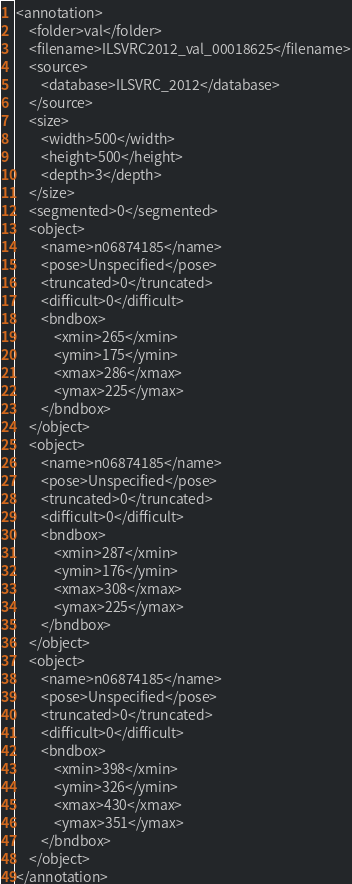<code> <loc_0><loc_0><loc_500><loc_500><_XML_><annotation>
	<folder>val</folder>
	<filename>ILSVRC2012_val_00018625</filename>
	<source>
		<database>ILSVRC_2012</database>
	</source>
	<size>
		<width>500</width>
		<height>500</height>
		<depth>3</depth>
	</size>
	<segmented>0</segmented>
	<object>
		<name>n06874185</name>
		<pose>Unspecified</pose>
		<truncated>0</truncated>
		<difficult>0</difficult>
		<bndbox>
			<xmin>265</xmin>
			<ymin>175</ymin>
			<xmax>286</xmax>
			<ymax>225</ymax>
		</bndbox>
	</object>
	<object>
		<name>n06874185</name>
		<pose>Unspecified</pose>
		<truncated>0</truncated>
		<difficult>0</difficult>
		<bndbox>
			<xmin>287</xmin>
			<ymin>176</ymin>
			<xmax>308</xmax>
			<ymax>225</ymax>
		</bndbox>
	</object>
	<object>
		<name>n06874185</name>
		<pose>Unspecified</pose>
		<truncated>0</truncated>
		<difficult>0</difficult>
		<bndbox>
			<xmin>398</xmin>
			<ymin>326</ymin>
			<xmax>430</xmax>
			<ymax>351</ymax>
		</bndbox>
	</object>
</annotation></code> 